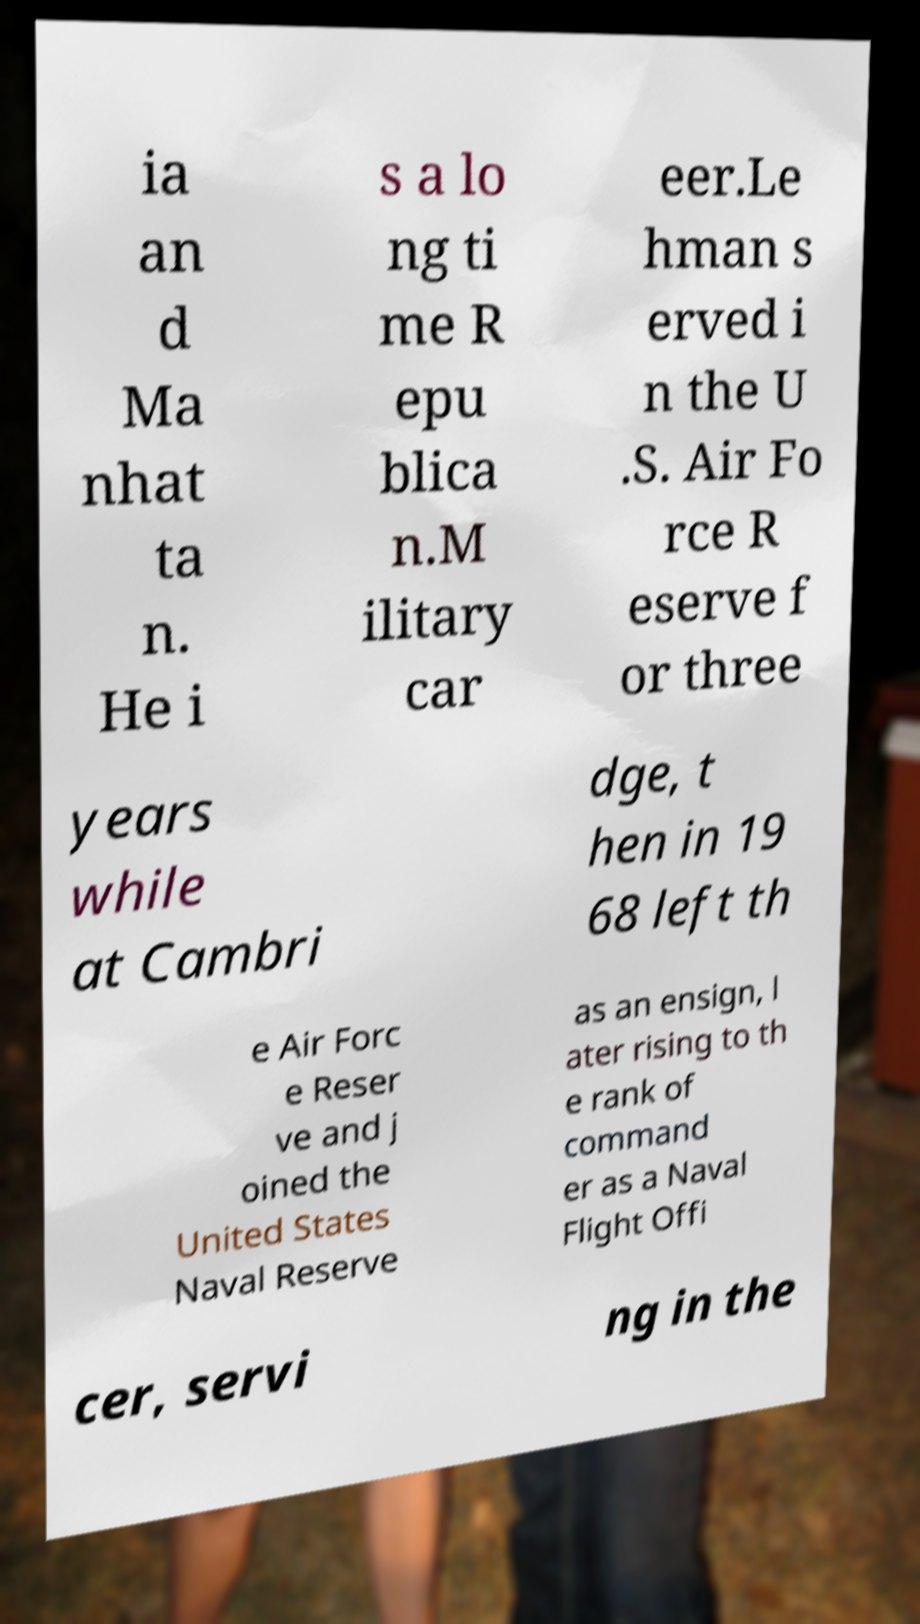Could you extract and type out the text from this image? ia an d Ma nhat ta n. He i s a lo ng ti me R epu blica n.M ilitary car eer.Le hman s erved i n the U .S. Air Fo rce R eserve f or three years while at Cambri dge, t hen in 19 68 left th e Air Forc e Reser ve and j oined the United States Naval Reserve as an ensign, l ater rising to th e rank of command er as a Naval Flight Offi cer, servi ng in the 